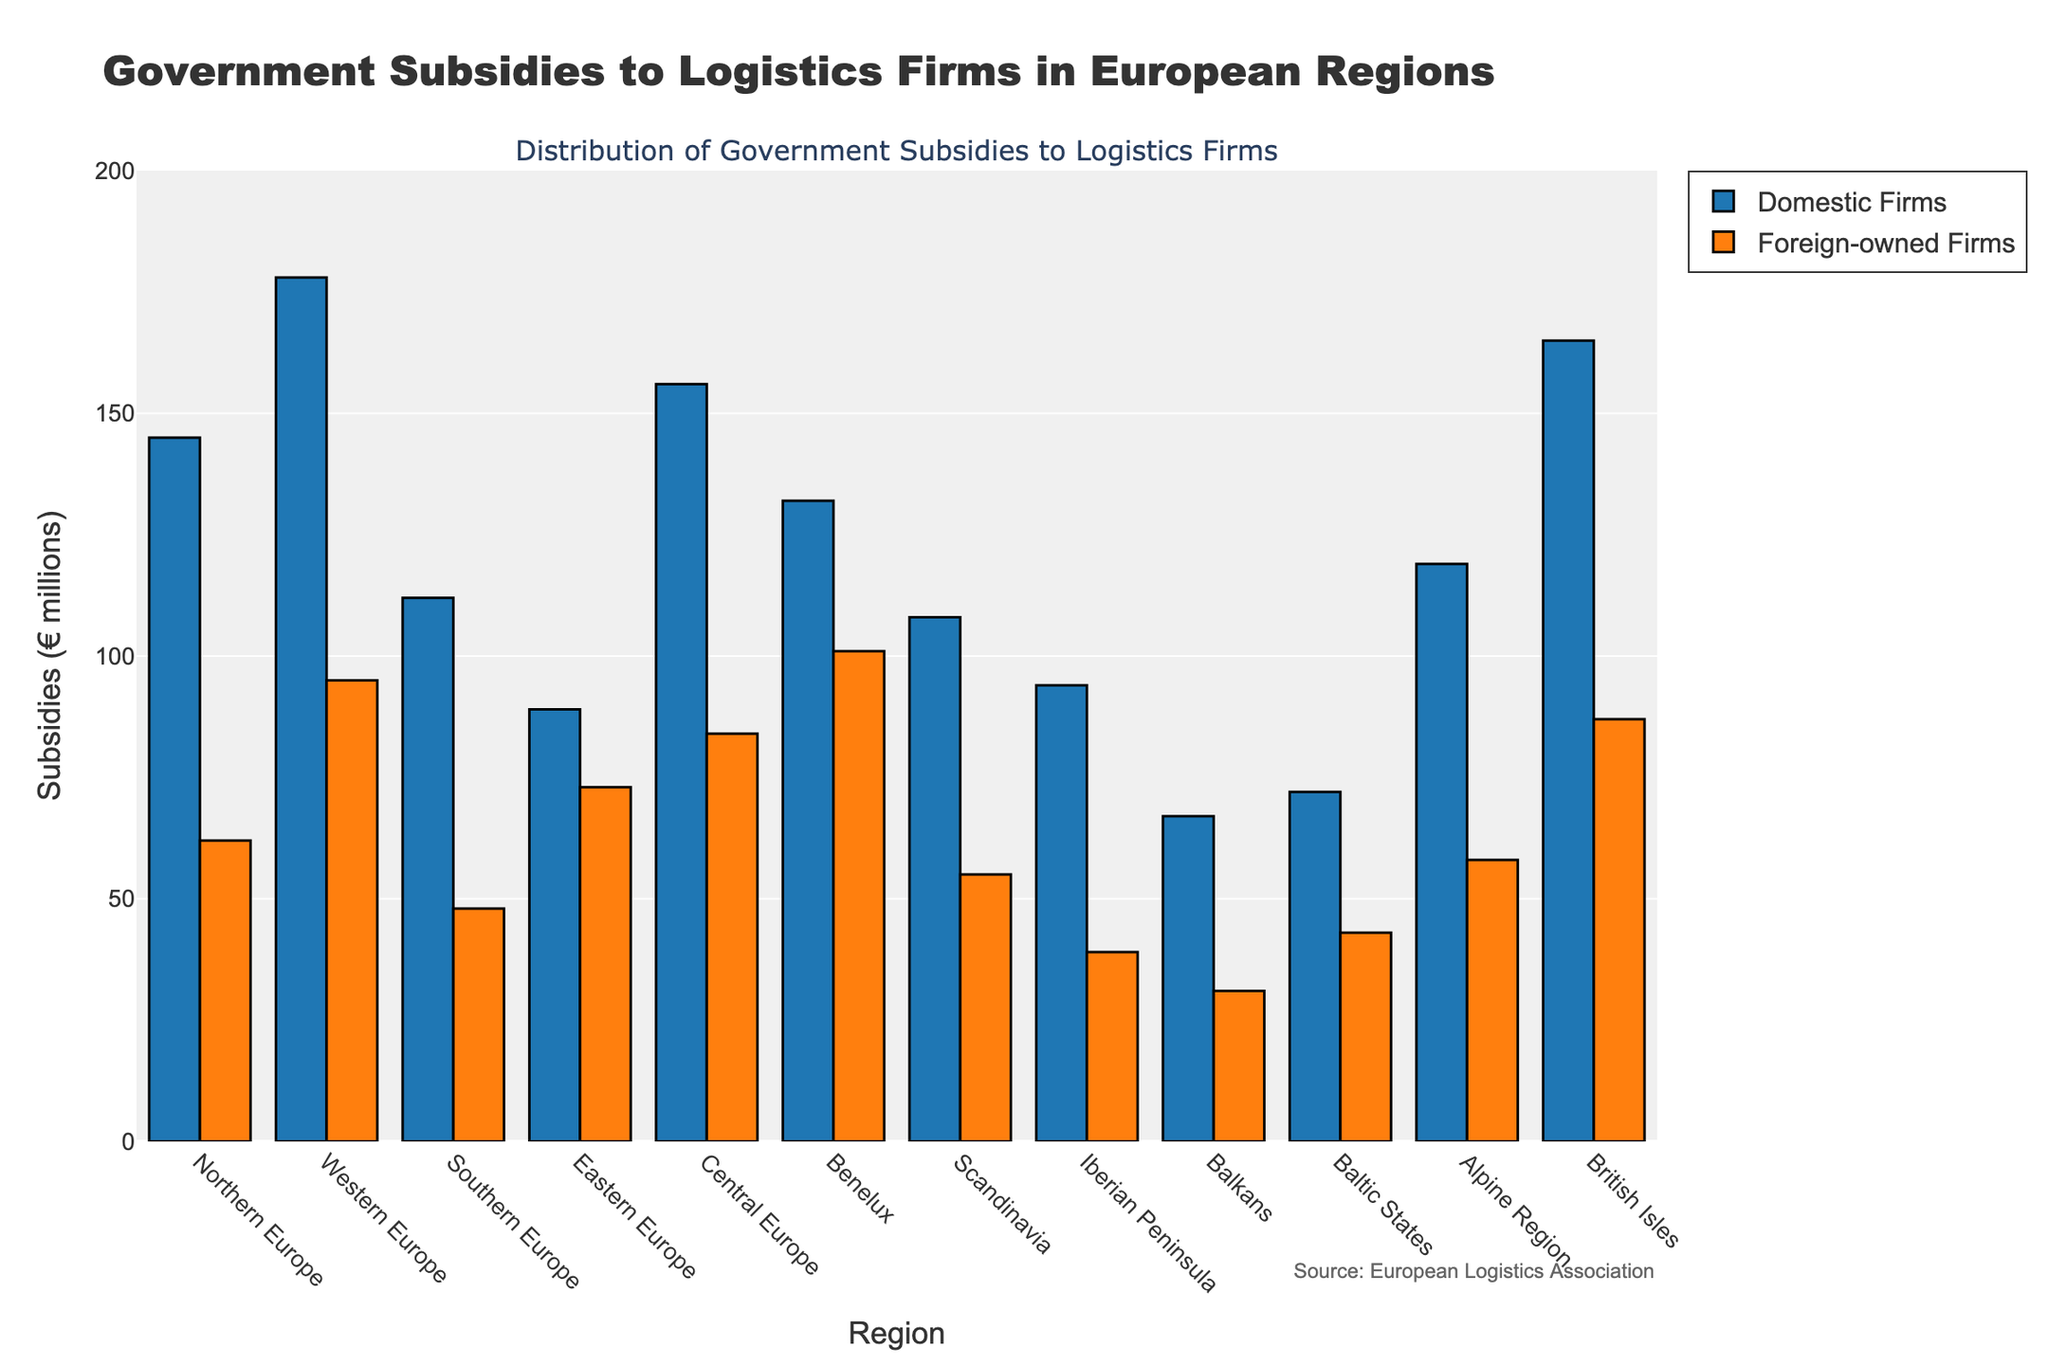Which region received the highest total subsidies for domestic firms? First, check the height of the bars representing domestic firms' subsidies for all regions. The highest bar corresponds to Western Europe.
Answer: Western Europe In which region is the difference between subsidies for domestic and foreign-owned firms the smallest? Calculate the absolute difference between domestic and foreign-owned firms' subsidies for each region. The smallest difference is found in the Balkan region (67M - 31M = 36M).
Answer: Balkans Which regions have higher subsidies for foreign-owned firms compared to domestic firms? Compare the heights of the foreign-owned firms' bars to the domestic firms' bars for each region. In none of the regions, the subsidies for foreign-owned firms are higher than domestic firms.
Answer: None What is the total subsidy amount given to both domestic and foreign-owned firms in Northern Europe? Sum up the subsidies for domestic and foreign-owned firms in Northern Europe. 145M for domestic + 62M for foreign-owned = 207M.
Answer: 207M Which region received exactly 67 million euros in subsidies for domestic firms? Identify the region by looking for the bar with a height of 67M under domestic firms, which is the Balkans.
Answer: Balkans Compare the subsidies for domestic firms in Benelux and the British Isles. Which received more, and by how much? Subtract the subsidy amount of Benelux from that of the British Isles. 165M (British Isles) - 132M (Benelux) = 33M.
Answer: British Isles, by 33M What is the average subsidy amount for foreign-owned firms across all regions? Add up all the subsidies for foreign-owned firms and divide by the total number of regions. (62 + 95 + 48 + 73 + 84 + 101 + 55 + 39 + 31 + 43 + 58 + 87)M / 12 = 776M/12 ≈ 64.67M.
Answer: 64.67M Which region has the highest combined subsidies when considering both domestic and foreign-owned firms? Calculate the total subsidies for each region by summing the domestic and foreign-owned subsidies. The region with the highest combined subsidies is Western Europe with 273M (178M + 95M).
Answer: Western Europe 